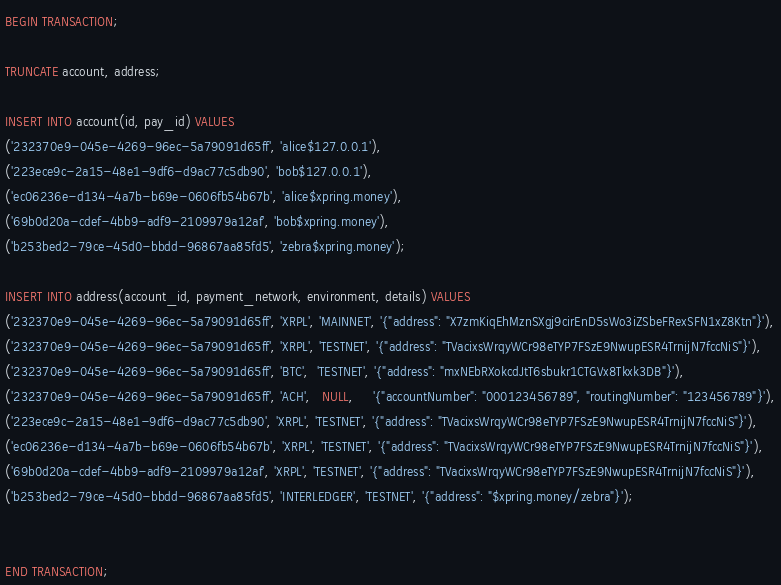<code> <loc_0><loc_0><loc_500><loc_500><_SQL_>BEGIN TRANSACTION;

TRUNCATE account, address;

INSERT INTO account(id, pay_id) VALUES
('232370e9-045e-4269-96ec-5a79091d65ff', 'alice$127.0.0.1'),
('223ece9c-2a15-48e1-9df6-d9ac77c5db90', 'bob$127.0.0.1'),
('ec06236e-d134-4a7b-b69e-0606fb54b67b', 'alice$xpring.money'),
('69b0d20a-cdef-4bb9-adf9-2109979a12af', 'bob$xpring.money'),
('b253bed2-79ce-45d0-bbdd-96867aa85fd5', 'zebra$xpring.money');

INSERT INTO address(account_id, payment_network, environment, details) VALUES
('232370e9-045e-4269-96ec-5a79091d65ff', 'XRPL', 'MAINNET', '{"address": "X7zmKiqEhMznSXgj9cirEnD5sWo3iZSbeFRexSFN1xZ8Ktn"}'),
('232370e9-045e-4269-96ec-5a79091d65ff', 'XRPL', 'TESTNET', '{"address": "TVacixsWrqyWCr98eTYP7FSzE9NwupESR4TrnijN7fccNiS"}'),
('232370e9-045e-4269-96ec-5a79091d65ff', 'BTC',  'TESTNET', '{"address": "mxNEbRXokcdJtT6sbukr1CTGVx8Tkxk3DB"}'),
('232370e9-045e-4269-96ec-5a79091d65ff', 'ACH',   NULL,     '{"accountNumber": "000123456789", "routingNumber": "123456789"}'),
('223ece9c-2a15-48e1-9df6-d9ac77c5db90', 'XRPL', 'TESTNET', '{"address": "TVacixsWrqyWCr98eTYP7FSzE9NwupESR4TrnijN7fccNiS"}'),
('ec06236e-d134-4a7b-b69e-0606fb54b67b', 'XRPL', 'TESTNET', '{"address": "TVacixsWrqyWCr98eTYP7FSzE9NwupESR4TrnijN7fccNiS"}'),
('69b0d20a-cdef-4bb9-adf9-2109979a12af', 'XRPL', 'TESTNET', '{"address": "TVacixsWrqyWCr98eTYP7FSzE9NwupESR4TrnijN7fccNiS"}'),
('b253bed2-79ce-45d0-bbdd-96867aa85fd5', 'INTERLEDGER', 'TESTNET', '{"address": "$xpring.money/zebra"}');


END TRANSACTION;
</code> 